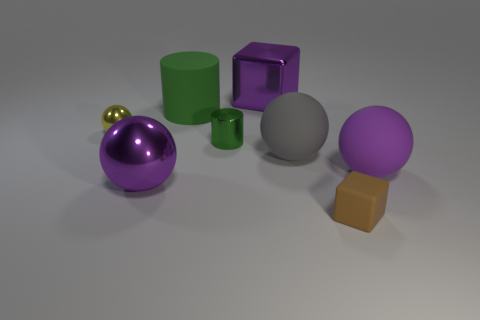There is another cylinder that is the same color as the large cylinder; what is its material?
Your response must be concise. Metal. Do the big shiny cube and the large metallic sphere have the same color?
Make the answer very short. Yes. There is a block that is left of the brown cube; is its size the same as the yellow sphere?
Give a very brief answer. No. Are the tiny brown cube and the big purple sphere that is left of the brown matte object made of the same material?
Offer a terse response. No. How many yellow objects are rubber things or big objects?
Make the answer very short. 0. Are any big gray metal objects visible?
Your answer should be compact. No. There is a matte object that is in front of the large purple metal ball that is on the left side of the large purple rubber sphere; is there a rubber ball on the right side of it?
Your answer should be very brief. Yes. Does the small green metallic object have the same shape as the large matte object that is behind the small green object?
Your response must be concise. Yes. What is the color of the metal sphere left of the metallic thing that is in front of the big purple ball to the right of the large cylinder?
Offer a terse response. Yellow. How many things are large rubber things that are behind the small yellow sphere or large things in front of the big green rubber object?
Your answer should be very brief. 4. 